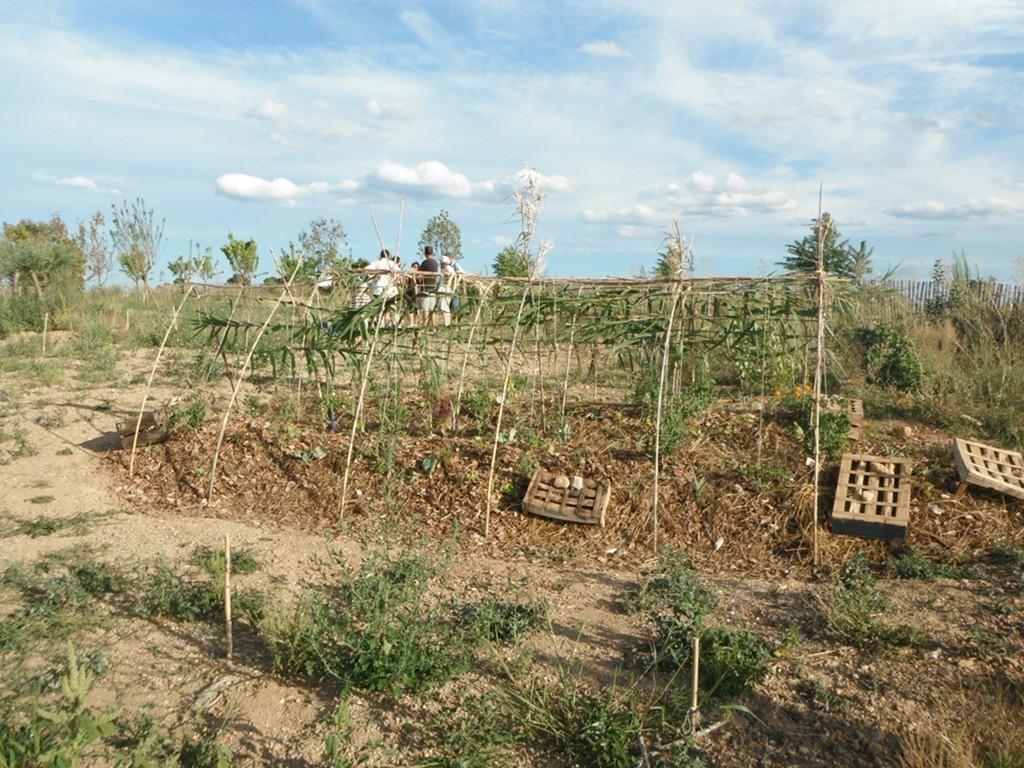Describe this image in one or two sentences. In this image, we can see few trees, plants, sticks. Here we can see a group of people are standing on the ground. Top of the image, we can see a cloudy sky. 